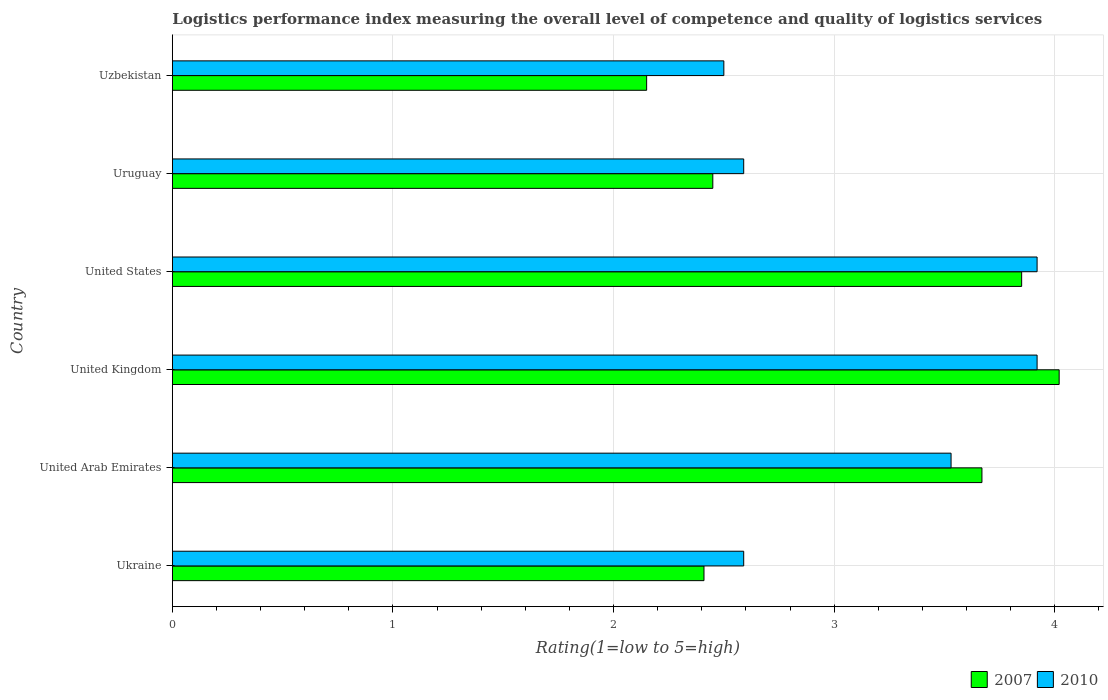How many different coloured bars are there?
Your response must be concise. 2. Are the number of bars per tick equal to the number of legend labels?
Your response must be concise. Yes. How many bars are there on the 2nd tick from the top?
Provide a short and direct response. 2. What is the Logistic performance index in 2010 in United Arab Emirates?
Provide a succinct answer. 3.53. Across all countries, what is the maximum Logistic performance index in 2007?
Your response must be concise. 4.02. In which country was the Logistic performance index in 2007 minimum?
Ensure brevity in your answer.  Uzbekistan. What is the total Logistic performance index in 2007 in the graph?
Offer a very short reply. 18.55. What is the difference between the Logistic performance index in 2010 in Ukraine and that in Uzbekistan?
Keep it short and to the point. 0.09. What is the difference between the Logistic performance index in 2010 in Uzbekistan and the Logistic performance index in 2007 in Uruguay?
Offer a terse response. 0.05. What is the average Logistic performance index in 2007 per country?
Provide a succinct answer. 3.09. What is the difference between the Logistic performance index in 2010 and Logistic performance index in 2007 in United States?
Make the answer very short. 0.07. In how many countries, is the Logistic performance index in 2007 greater than 2.2 ?
Your answer should be very brief. 5. What is the ratio of the Logistic performance index in 2010 in United Arab Emirates to that in United Kingdom?
Your answer should be compact. 0.9. What is the difference between the highest and the second highest Logistic performance index in 2007?
Offer a terse response. 0.17. What is the difference between the highest and the lowest Logistic performance index in 2007?
Offer a terse response. 1.87. What does the 1st bar from the top in Uruguay represents?
Offer a terse response. 2010. Are all the bars in the graph horizontal?
Provide a short and direct response. Yes. How many countries are there in the graph?
Your answer should be very brief. 6. What is the difference between two consecutive major ticks on the X-axis?
Provide a succinct answer. 1. Does the graph contain any zero values?
Keep it short and to the point. No. Does the graph contain grids?
Give a very brief answer. Yes. What is the title of the graph?
Keep it short and to the point. Logistics performance index measuring the overall level of competence and quality of logistics services. Does "2004" appear as one of the legend labels in the graph?
Your answer should be compact. No. What is the label or title of the X-axis?
Provide a succinct answer. Rating(1=low to 5=high). What is the label or title of the Y-axis?
Provide a short and direct response. Country. What is the Rating(1=low to 5=high) in 2007 in Ukraine?
Make the answer very short. 2.41. What is the Rating(1=low to 5=high) of 2010 in Ukraine?
Your answer should be very brief. 2.59. What is the Rating(1=low to 5=high) of 2007 in United Arab Emirates?
Make the answer very short. 3.67. What is the Rating(1=low to 5=high) in 2010 in United Arab Emirates?
Make the answer very short. 3.53. What is the Rating(1=low to 5=high) in 2007 in United Kingdom?
Provide a short and direct response. 4.02. What is the Rating(1=low to 5=high) of 2010 in United Kingdom?
Your response must be concise. 3.92. What is the Rating(1=low to 5=high) in 2007 in United States?
Provide a succinct answer. 3.85. What is the Rating(1=low to 5=high) of 2010 in United States?
Give a very brief answer. 3.92. What is the Rating(1=low to 5=high) of 2007 in Uruguay?
Your answer should be very brief. 2.45. What is the Rating(1=low to 5=high) of 2010 in Uruguay?
Give a very brief answer. 2.59. What is the Rating(1=low to 5=high) of 2007 in Uzbekistan?
Your response must be concise. 2.15. What is the Rating(1=low to 5=high) in 2010 in Uzbekistan?
Your answer should be very brief. 2.5. Across all countries, what is the maximum Rating(1=low to 5=high) of 2007?
Ensure brevity in your answer.  4.02. Across all countries, what is the maximum Rating(1=low to 5=high) of 2010?
Ensure brevity in your answer.  3.92. Across all countries, what is the minimum Rating(1=low to 5=high) in 2007?
Offer a terse response. 2.15. Across all countries, what is the minimum Rating(1=low to 5=high) of 2010?
Provide a succinct answer. 2.5. What is the total Rating(1=low to 5=high) of 2007 in the graph?
Your response must be concise. 18.55. What is the total Rating(1=low to 5=high) in 2010 in the graph?
Provide a short and direct response. 19.05. What is the difference between the Rating(1=low to 5=high) of 2007 in Ukraine and that in United Arab Emirates?
Offer a terse response. -1.26. What is the difference between the Rating(1=low to 5=high) of 2010 in Ukraine and that in United Arab Emirates?
Offer a terse response. -0.94. What is the difference between the Rating(1=low to 5=high) in 2007 in Ukraine and that in United Kingdom?
Make the answer very short. -1.61. What is the difference between the Rating(1=low to 5=high) in 2010 in Ukraine and that in United Kingdom?
Offer a terse response. -1.33. What is the difference between the Rating(1=low to 5=high) of 2007 in Ukraine and that in United States?
Ensure brevity in your answer.  -1.44. What is the difference between the Rating(1=low to 5=high) of 2010 in Ukraine and that in United States?
Give a very brief answer. -1.33. What is the difference between the Rating(1=low to 5=high) of 2007 in Ukraine and that in Uruguay?
Give a very brief answer. -0.04. What is the difference between the Rating(1=low to 5=high) in 2007 in Ukraine and that in Uzbekistan?
Ensure brevity in your answer.  0.26. What is the difference between the Rating(1=low to 5=high) of 2010 in Ukraine and that in Uzbekistan?
Provide a succinct answer. 0.09. What is the difference between the Rating(1=low to 5=high) of 2007 in United Arab Emirates and that in United Kingdom?
Keep it short and to the point. -0.35. What is the difference between the Rating(1=low to 5=high) in 2010 in United Arab Emirates and that in United Kingdom?
Make the answer very short. -0.39. What is the difference between the Rating(1=low to 5=high) of 2007 in United Arab Emirates and that in United States?
Your answer should be very brief. -0.18. What is the difference between the Rating(1=low to 5=high) in 2010 in United Arab Emirates and that in United States?
Your answer should be very brief. -0.39. What is the difference between the Rating(1=low to 5=high) of 2007 in United Arab Emirates and that in Uruguay?
Make the answer very short. 1.22. What is the difference between the Rating(1=low to 5=high) in 2007 in United Arab Emirates and that in Uzbekistan?
Your answer should be very brief. 1.52. What is the difference between the Rating(1=low to 5=high) in 2007 in United Kingdom and that in United States?
Your response must be concise. 0.17. What is the difference between the Rating(1=low to 5=high) of 2010 in United Kingdom and that in United States?
Give a very brief answer. 0. What is the difference between the Rating(1=low to 5=high) in 2007 in United Kingdom and that in Uruguay?
Offer a very short reply. 1.57. What is the difference between the Rating(1=low to 5=high) in 2010 in United Kingdom and that in Uruguay?
Your response must be concise. 1.33. What is the difference between the Rating(1=low to 5=high) in 2007 in United Kingdom and that in Uzbekistan?
Keep it short and to the point. 1.87. What is the difference between the Rating(1=low to 5=high) in 2010 in United Kingdom and that in Uzbekistan?
Keep it short and to the point. 1.42. What is the difference between the Rating(1=low to 5=high) of 2007 in United States and that in Uruguay?
Your response must be concise. 1.4. What is the difference between the Rating(1=low to 5=high) in 2010 in United States and that in Uruguay?
Ensure brevity in your answer.  1.33. What is the difference between the Rating(1=low to 5=high) of 2007 in United States and that in Uzbekistan?
Ensure brevity in your answer.  1.7. What is the difference between the Rating(1=low to 5=high) in 2010 in United States and that in Uzbekistan?
Provide a short and direct response. 1.42. What is the difference between the Rating(1=low to 5=high) of 2010 in Uruguay and that in Uzbekistan?
Your answer should be very brief. 0.09. What is the difference between the Rating(1=low to 5=high) in 2007 in Ukraine and the Rating(1=low to 5=high) in 2010 in United Arab Emirates?
Offer a very short reply. -1.12. What is the difference between the Rating(1=low to 5=high) of 2007 in Ukraine and the Rating(1=low to 5=high) of 2010 in United Kingdom?
Your response must be concise. -1.51. What is the difference between the Rating(1=low to 5=high) in 2007 in Ukraine and the Rating(1=low to 5=high) in 2010 in United States?
Provide a short and direct response. -1.51. What is the difference between the Rating(1=low to 5=high) of 2007 in Ukraine and the Rating(1=low to 5=high) of 2010 in Uruguay?
Keep it short and to the point. -0.18. What is the difference between the Rating(1=low to 5=high) in 2007 in Ukraine and the Rating(1=low to 5=high) in 2010 in Uzbekistan?
Make the answer very short. -0.09. What is the difference between the Rating(1=low to 5=high) of 2007 in United Arab Emirates and the Rating(1=low to 5=high) of 2010 in Uzbekistan?
Ensure brevity in your answer.  1.17. What is the difference between the Rating(1=low to 5=high) of 2007 in United Kingdom and the Rating(1=low to 5=high) of 2010 in United States?
Provide a short and direct response. 0.1. What is the difference between the Rating(1=low to 5=high) of 2007 in United Kingdom and the Rating(1=low to 5=high) of 2010 in Uruguay?
Your answer should be compact. 1.43. What is the difference between the Rating(1=low to 5=high) of 2007 in United Kingdom and the Rating(1=low to 5=high) of 2010 in Uzbekistan?
Offer a terse response. 1.52. What is the difference between the Rating(1=low to 5=high) in 2007 in United States and the Rating(1=low to 5=high) in 2010 in Uruguay?
Provide a succinct answer. 1.26. What is the difference between the Rating(1=low to 5=high) of 2007 in United States and the Rating(1=low to 5=high) of 2010 in Uzbekistan?
Your answer should be very brief. 1.35. What is the average Rating(1=low to 5=high) of 2007 per country?
Keep it short and to the point. 3.09. What is the average Rating(1=low to 5=high) in 2010 per country?
Offer a very short reply. 3.17. What is the difference between the Rating(1=low to 5=high) of 2007 and Rating(1=low to 5=high) of 2010 in Ukraine?
Your answer should be very brief. -0.18. What is the difference between the Rating(1=low to 5=high) in 2007 and Rating(1=low to 5=high) in 2010 in United Arab Emirates?
Make the answer very short. 0.14. What is the difference between the Rating(1=low to 5=high) of 2007 and Rating(1=low to 5=high) of 2010 in United States?
Make the answer very short. -0.07. What is the difference between the Rating(1=low to 5=high) in 2007 and Rating(1=low to 5=high) in 2010 in Uruguay?
Give a very brief answer. -0.14. What is the difference between the Rating(1=low to 5=high) in 2007 and Rating(1=low to 5=high) in 2010 in Uzbekistan?
Offer a terse response. -0.35. What is the ratio of the Rating(1=low to 5=high) of 2007 in Ukraine to that in United Arab Emirates?
Provide a succinct answer. 0.66. What is the ratio of the Rating(1=low to 5=high) of 2010 in Ukraine to that in United Arab Emirates?
Keep it short and to the point. 0.73. What is the ratio of the Rating(1=low to 5=high) in 2007 in Ukraine to that in United Kingdom?
Provide a succinct answer. 0.6. What is the ratio of the Rating(1=low to 5=high) of 2010 in Ukraine to that in United Kingdom?
Offer a terse response. 0.66. What is the ratio of the Rating(1=low to 5=high) of 2007 in Ukraine to that in United States?
Give a very brief answer. 0.63. What is the ratio of the Rating(1=low to 5=high) in 2010 in Ukraine to that in United States?
Ensure brevity in your answer.  0.66. What is the ratio of the Rating(1=low to 5=high) of 2007 in Ukraine to that in Uruguay?
Keep it short and to the point. 0.98. What is the ratio of the Rating(1=low to 5=high) of 2007 in Ukraine to that in Uzbekistan?
Your answer should be very brief. 1.12. What is the ratio of the Rating(1=low to 5=high) of 2010 in Ukraine to that in Uzbekistan?
Provide a short and direct response. 1.04. What is the ratio of the Rating(1=low to 5=high) in 2007 in United Arab Emirates to that in United Kingdom?
Keep it short and to the point. 0.91. What is the ratio of the Rating(1=low to 5=high) in 2010 in United Arab Emirates to that in United Kingdom?
Provide a short and direct response. 0.9. What is the ratio of the Rating(1=low to 5=high) in 2007 in United Arab Emirates to that in United States?
Your response must be concise. 0.95. What is the ratio of the Rating(1=low to 5=high) in 2010 in United Arab Emirates to that in United States?
Offer a very short reply. 0.9. What is the ratio of the Rating(1=low to 5=high) of 2007 in United Arab Emirates to that in Uruguay?
Give a very brief answer. 1.5. What is the ratio of the Rating(1=low to 5=high) of 2010 in United Arab Emirates to that in Uruguay?
Your response must be concise. 1.36. What is the ratio of the Rating(1=low to 5=high) of 2007 in United Arab Emirates to that in Uzbekistan?
Provide a short and direct response. 1.71. What is the ratio of the Rating(1=low to 5=high) in 2010 in United Arab Emirates to that in Uzbekistan?
Your response must be concise. 1.41. What is the ratio of the Rating(1=low to 5=high) in 2007 in United Kingdom to that in United States?
Your response must be concise. 1.04. What is the ratio of the Rating(1=low to 5=high) in 2007 in United Kingdom to that in Uruguay?
Give a very brief answer. 1.64. What is the ratio of the Rating(1=low to 5=high) of 2010 in United Kingdom to that in Uruguay?
Provide a short and direct response. 1.51. What is the ratio of the Rating(1=low to 5=high) of 2007 in United Kingdom to that in Uzbekistan?
Keep it short and to the point. 1.87. What is the ratio of the Rating(1=low to 5=high) of 2010 in United Kingdom to that in Uzbekistan?
Your answer should be compact. 1.57. What is the ratio of the Rating(1=low to 5=high) in 2007 in United States to that in Uruguay?
Your answer should be compact. 1.57. What is the ratio of the Rating(1=low to 5=high) in 2010 in United States to that in Uruguay?
Your answer should be compact. 1.51. What is the ratio of the Rating(1=low to 5=high) in 2007 in United States to that in Uzbekistan?
Keep it short and to the point. 1.79. What is the ratio of the Rating(1=low to 5=high) of 2010 in United States to that in Uzbekistan?
Ensure brevity in your answer.  1.57. What is the ratio of the Rating(1=low to 5=high) in 2007 in Uruguay to that in Uzbekistan?
Your answer should be very brief. 1.14. What is the ratio of the Rating(1=low to 5=high) of 2010 in Uruguay to that in Uzbekistan?
Provide a short and direct response. 1.04. What is the difference between the highest and the second highest Rating(1=low to 5=high) of 2007?
Your answer should be very brief. 0.17. What is the difference between the highest and the lowest Rating(1=low to 5=high) of 2007?
Provide a short and direct response. 1.87. What is the difference between the highest and the lowest Rating(1=low to 5=high) of 2010?
Keep it short and to the point. 1.42. 